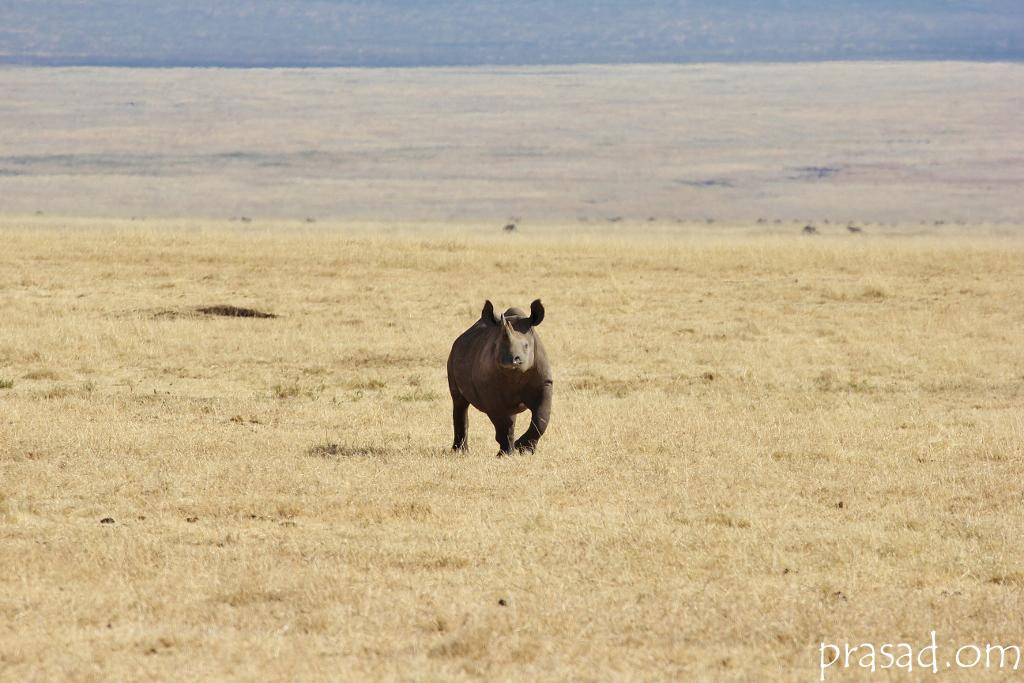What animal is featured in the image? There is a black color rhinoceros in the image. What is the rhinoceros doing in the image? The rhinoceros is running in the dry grass. What can be seen in the background of the image? There is a yellow color big grass ground in the background of the image. What type of beef is being served on the plate in the image? There is no plate or beef present in the image; it features a black color rhinoceros running in the dry grass with a yellow color big grass ground in the background. 